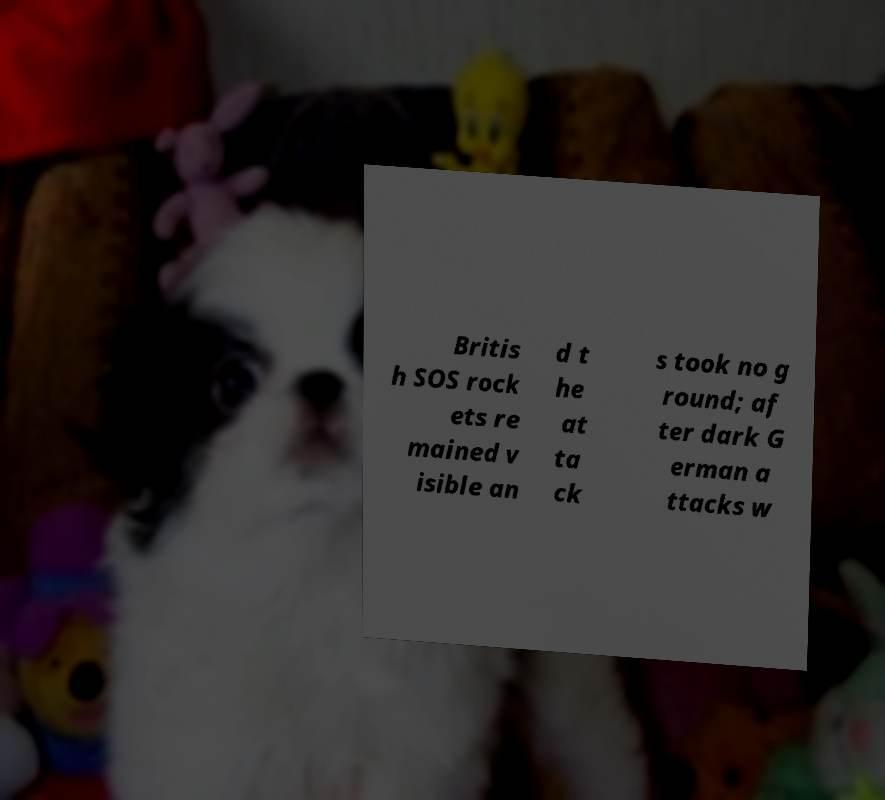There's text embedded in this image that I need extracted. Can you transcribe it verbatim? Britis h SOS rock ets re mained v isible an d t he at ta ck s took no g round; af ter dark G erman a ttacks w 